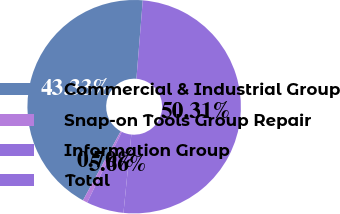Convert chart to OTSL. <chart><loc_0><loc_0><loc_500><loc_500><pie_chart><fcel>Commercial & Industrial Group<fcel>Snap-on Tools Group Repair<fcel>Information Group<fcel>Total<nl><fcel>43.33%<fcel>0.7%<fcel>5.66%<fcel>50.31%<nl></chart> 